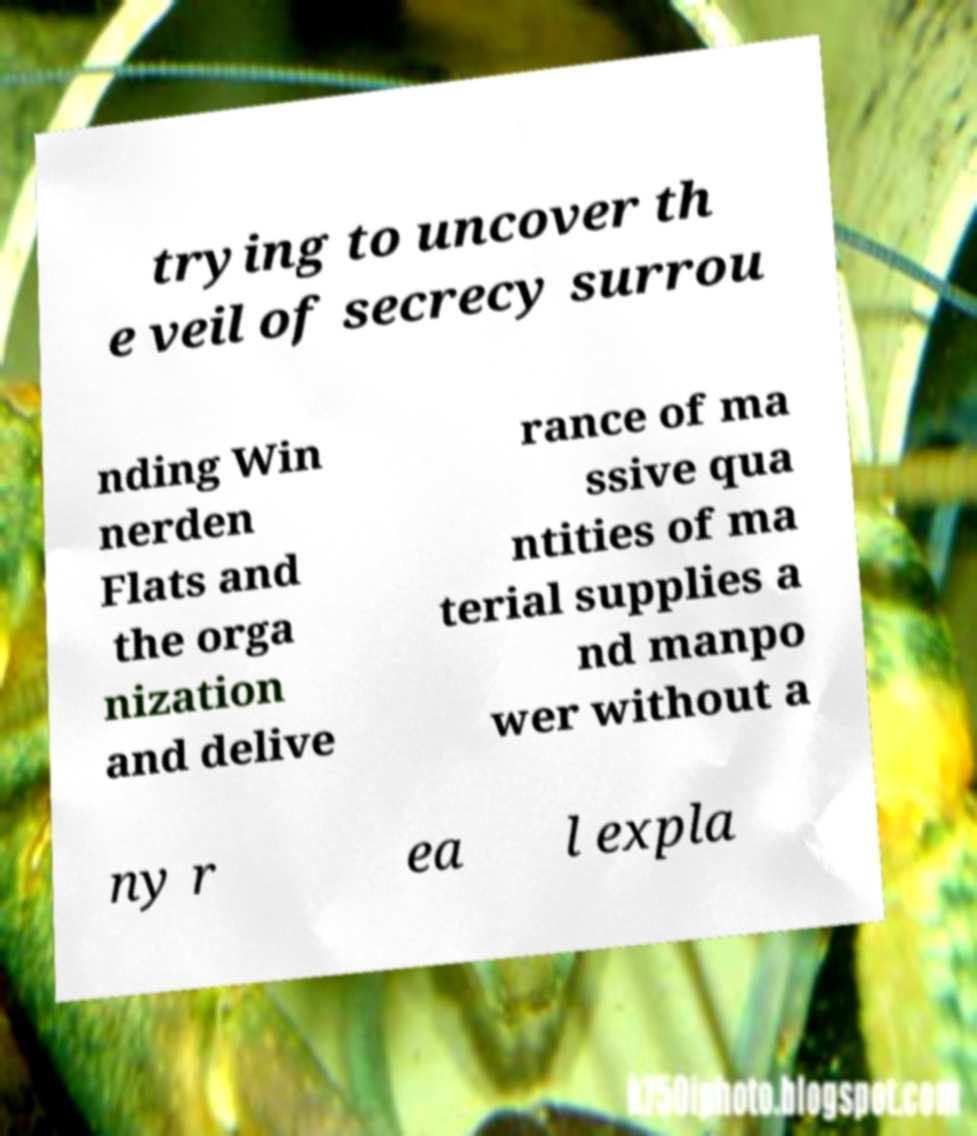Could you assist in decoding the text presented in this image and type it out clearly? trying to uncover th e veil of secrecy surrou nding Win nerden Flats and the orga nization and delive rance of ma ssive qua ntities of ma terial supplies a nd manpo wer without a ny r ea l expla 